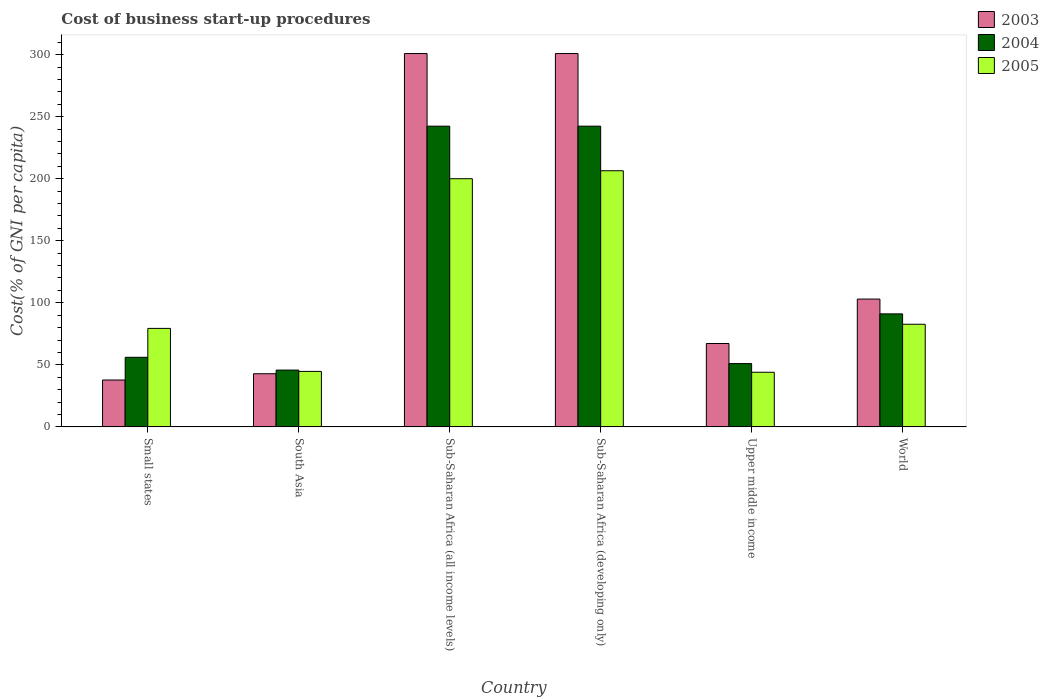How many different coloured bars are there?
Offer a very short reply. 3. How many bars are there on the 5th tick from the left?
Offer a very short reply. 3. How many bars are there on the 5th tick from the right?
Make the answer very short. 3. What is the label of the 1st group of bars from the left?
Offer a terse response. Small states. In how many cases, is the number of bars for a given country not equal to the number of legend labels?
Offer a terse response. 0. What is the cost of business start-up procedures in 2003 in Sub-Saharan Africa (developing only)?
Provide a short and direct response. 300.87. Across all countries, what is the maximum cost of business start-up procedures in 2005?
Provide a short and direct response. 206.42. Across all countries, what is the minimum cost of business start-up procedures in 2004?
Offer a terse response. 45.76. In which country was the cost of business start-up procedures in 2005 maximum?
Your answer should be very brief. Sub-Saharan Africa (developing only). In which country was the cost of business start-up procedures in 2005 minimum?
Offer a terse response. Upper middle income. What is the total cost of business start-up procedures in 2004 in the graph?
Your answer should be compact. 728.58. What is the difference between the cost of business start-up procedures in 2004 in Small states and that in World?
Your answer should be compact. -34.99. What is the difference between the cost of business start-up procedures in 2004 in Sub-Saharan Africa (developing only) and the cost of business start-up procedures in 2003 in Small states?
Make the answer very short. 204.57. What is the average cost of business start-up procedures in 2003 per country?
Your answer should be very brief. 142.09. What is the difference between the cost of business start-up procedures of/in 2005 and cost of business start-up procedures of/in 2003 in Small states?
Give a very brief answer. 41.58. What is the ratio of the cost of business start-up procedures in 2004 in South Asia to that in World?
Your response must be concise. 0.5. What is the difference between the highest and the second highest cost of business start-up procedures in 2004?
Provide a succinct answer. 151.29. What is the difference between the highest and the lowest cost of business start-up procedures in 2004?
Offer a very short reply. 196.59. In how many countries, is the cost of business start-up procedures in 2004 greater than the average cost of business start-up procedures in 2004 taken over all countries?
Provide a succinct answer. 2. Is the sum of the cost of business start-up procedures in 2005 in Small states and Sub-Saharan Africa (developing only) greater than the maximum cost of business start-up procedures in 2003 across all countries?
Give a very brief answer. No. What does the 3rd bar from the left in Sub-Saharan Africa (developing only) represents?
Your answer should be very brief. 2005. Is it the case that in every country, the sum of the cost of business start-up procedures in 2005 and cost of business start-up procedures in 2004 is greater than the cost of business start-up procedures in 2003?
Your response must be concise. Yes. Are all the bars in the graph horizontal?
Keep it short and to the point. No. Are the values on the major ticks of Y-axis written in scientific E-notation?
Provide a succinct answer. No. Does the graph contain grids?
Your response must be concise. No. What is the title of the graph?
Ensure brevity in your answer.  Cost of business start-up procedures. Does "1974" appear as one of the legend labels in the graph?
Make the answer very short. No. What is the label or title of the Y-axis?
Offer a terse response. Cost(% of GNI per capita). What is the Cost(% of GNI per capita) of 2003 in Small states?
Make the answer very short. 37.77. What is the Cost(% of GNI per capita) in 2004 in Small states?
Your answer should be very brief. 56.07. What is the Cost(% of GNI per capita) in 2005 in Small states?
Keep it short and to the point. 79.36. What is the Cost(% of GNI per capita) of 2003 in South Asia?
Your answer should be very brief. 42.83. What is the Cost(% of GNI per capita) in 2004 in South Asia?
Offer a terse response. 45.76. What is the Cost(% of GNI per capita) of 2005 in South Asia?
Your response must be concise. 44.7. What is the Cost(% of GNI per capita) of 2003 in Sub-Saharan Africa (all income levels)?
Keep it short and to the point. 300.87. What is the Cost(% of GNI per capita) in 2004 in Sub-Saharan Africa (all income levels)?
Give a very brief answer. 242.35. What is the Cost(% of GNI per capita) of 2005 in Sub-Saharan Africa (all income levels)?
Your answer should be compact. 200. What is the Cost(% of GNI per capita) in 2003 in Sub-Saharan Africa (developing only)?
Offer a very short reply. 300.87. What is the Cost(% of GNI per capita) in 2004 in Sub-Saharan Africa (developing only)?
Provide a short and direct response. 242.35. What is the Cost(% of GNI per capita) of 2005 in Sub-Saharan Africa (developing only)?
Provide a short and direct response. 206.42. What is the Cost(% of GNI per capita) of 2003 in Upper middle income?
Make the answer very short. 67.19. What is the Cost(% of GNI per capita) in 2004 in Upper middle income?
Ensure brevity in your answer.  51. What is the Cost(% of GNI per capita) of 2005 in Upper middle income?
Provide a succinct answer. 44.01. What is the Cost(% of GNI per capita) in 2003 in World?
Your answer should be compact. 103. What is the Cost(% of GNI per capita) of 2004 in World?
Offer a very short reply. 91.06. What is the Cost(% of GNI per capita) of 2005 in World?
Ensure brevity in your answer.  82.7. Across all countries, what is the maximum Cost(% of GNI per capita) of 2003?
Your response must be concise. 300.87. Across all countries, what is the maximum Cost(% of GNI per capita) of 2004?
Keep it short and to the point. 242.35. Across all countries, what is the maximum Cost(% of GNI per capita) in 2005?
Your answer should be very brief. 206.42. Across all countries, what is the minimum Cost(% of GNI per capita) of 2003?
Provide a succinct answer. 37.77. Across all countries, what is the minimum Cost(% of GNI per capita) in 2004?
Ensure brevity in your answer.  45.76. Across all countries, what is the minimum Cost(% of GNI per capita) in 2005?
Your response must be concise. 44.01. What is the total Cost(% of GNI per capita) in 2003 in the graph?
Keep it short and to the point. 852.52. What is the total Cost(% of GNI per capita) in 2004 in the graph?
Make the answer very short. 728.58. What is the total Cost(% of GNI per capita) in 2005 in the graph?
Make the answer very short. 657.18. What is the difference between the Cost(% of GNI per capita) of 2003 in Small states and that in South Asia?
Your answer should be compact. -5.05. What is the difference between the Cost(% of GNI per capita) in 2004 in Small states and that in South Asia?
Provide a succinct answer. 10.31. What is the difference between the Cost(% of GNI per capita) in 2005 in Small states and that in South Asia?
Offer a very short reply. 34.66. What is the difference between the Cost(% of GNI per capita) of 2003 in Small states and that in Sub-Saharan Africa (all income levels)?
Your answer should be very brief. -263.1. What is the difference between the Cost(% of GNI per capita) of 2004 in Small states and that in Sub-Saharan Africa (all income levels)?
Your answer should be compact. -186.28. What is the difference between the Cost(% of GNI per capita) of 2005 in Small states and that in Sub-Saharan Africa (all income levels)?
Your response must be concise. -120.64. What is the difference between the Cost(% of GNI per capita) in 2003 in Small states and that in Sub-Saharan Africa (developing only)?
Ensure brevity in your answer.  -263.1. What is the difference between the Cost(% of GNI per capita) of 2004 in Small states and that in Sub-Saharan Africa (developing only)?
Give a very brief answer. -186.28. What is the difference between the Cost(% of GNI per capita) of 2005 in Small states and that in Sub-Saharan Africa (developing only)?
Ensure brevity in your answer.  -127.06. What is the difference between the Cost(% of GNI per capita) of 2003 in Small states and that in Upper middle income?
Ensure brevity in your answer.  -29.42. What is the difference between the Cost(% of GNI per capita) in 2004 in Small states and that in Upper middle income?
Offer a terse response. 5.07. What is the difference between the Cost(% of GNI per capita) of 2005 in Small states and that in Upper middle income?
Offer a very short reply. 35.35. What is the difference between the Cost(% of GNI per capita) of 2003 in Small states and that in World?
Provide a succinct answer. -65.22. What is the difference between the Cost(% of GNI per capita) in 2004 in Small states and that in World?
Keep it short and to the point. -34.99. What is the difference between the Cost(% of GNI per capita) in 2005 in Small states and that in World?
Provide a succinct answer. -3.34. What is the difference between the Cost(% of GNI per capita) of 2003 in South Asia and that in Sub-Saharan Africa (all income levels)?
Your answer should be compact. -258.04. What is the difference between the Cost(% of GNI per capita) of 2004 in South Asia and that in Sub-Saharan Africa (all income levels)?
Your answer should be very brief. -196.59. What is the difference between the Cost(% of GNI per capita) in 2005 in South Asia and that in Sub-Saharan Africa (all income levels)?
Give a very brief answer. -155.3. What is the difference between the Cost(% of GNI per capita) in 2003 in South Asia and that in Sub-Saharan Africa (developing only)?
Provide a short and direct response. -258.04. What is the difference between the Cost(% of GNI per capita) in 2004 in South Asia and that in Sub-Saharan Africa (developing only)?
Ensure brevity in your answer.  -196.59. What is the difference between the Cost(% of GNI per capita) of 2005 in South Asia and that in Sub-Saharan Africa (developing only)?
Make the answer very short. -161.72. What is the difference between the Cost(% of GNI per capita) of 2003 in South Asia and that in Upper middle income?
Make the answer very short. -24.36. What is the difference between the Cost(% of GNI per capita) in 2004 in South Asia and that in Upper middle income?
Your response must be concise. -5.24. What is the difference between the Cost(% of GNI per capita) in 2005 in South Asia and that in Upper middle income?
Your answer should be compact. 0.69. What is the difference between the Cost(% of GNI per capita) of 2003 in South Asia and that in World?
Your answer should be compact. -60.17. What is the difference between the Cost(% of GNI per capita) in 2004 in South Asia and that in World?
Offer a very short reply. -45.3. What is the difference between the Cost(% of GNI per capita) of 2005 in South Asia and that in World?
Offer a terse response. -38. What is the difference between the Cost(% of GNI per capita) in 2003 in Sub-Saharan Africa (all income levels) and that in Sub-Saharan Africa (developing only)?
Give a very brief answer. 0. What is the difference between the Cost(% of GNI per capita) in 2004 in Sub-Saharan Africa (all income levels) and that in Sub-Saharan Africa (developing only)?
Your response must be concise. 0. What is the difference between the Cost(% of GNI per capita) of 2005 in Sub-Saharan Africa (all income levels) and that in Sub-Saharan Africa (developing only)?
Keep it short and to the point. -6.42. What is the difference between the Cost(% of GNI per capita) in 2003 in Sub-Saharan Africa (all income levels) and that in Upper middle income?
Ensure brevity in your answer.  233.68. What is the difference between the Cost(% of GNI per capita) of 2004 in Sub-Saharan Africa (all income levels) and that in Upper middle income?
Ensure brevity in your answer.  191.35. What is the difference between the Cost(% of GNI per capita) of 2005 in Sub-Saharan Africa (all income levels) and that in Upper middle income?
Provide a short and direct response. 155.99. What is the difference between the Cost(% of GNI per capita) in 2003 in Sub-Saharan Africa (all income levels) and that in World?
Ensure brevity in your answer.  197.87. What is the difference between the Cost(% of GNI per capita) of 2004 in Sub-Saharan Africa (all income levels) and that in World?
Provide a succinct answer. 151.29. What is the difference between the Cost(% of GNI per capita) in 2005 in Sub-Saharan Africa (all income levels) and that in World?
Provide a short and direct response. 117.3. What is the difference between the Cost(% of GNI per capita) of 2003 in Sub-Saharan Africa (developing only) and that in Upper middle income?
Ensure brevity in your answer.  233.68. What is the difference between the Cost(% of GNI per capita) of 2004 in Sub-Saharan Africa (developing only) and that in Upper middle income?
Offer a very short reply. 191.35. What is the difference between the Cost(% of GNI per capita) in 2005 in Sub-Saharan Africa (developing only) and that in Upper middle income?
Make the answer very short. 162.41. What is the difference between the Cost(% of GNI per capita) in 2003 in Sub-Saharan Africa (developing only) and that in World?
Give a very brief answer. 197.87. What is the difference between the Cost(% of GNI per capita) of 2004 in Sub-Saharan Africa (developing only) and that in World?
Offer a terse response. 151.29. What is the difference between the Cost(% of GNI per capita) of 2005 in Sub-Saharan Africa (developing only) and that in World?
Provide a short and direct response. 123.72. What is the difference between the Cost(% of GNI per capita) in 2003 in Upper middle income and that in World?
Keep it short and to the point. -35.81. What is the difference between the Cost(% of GNI per capita) in 2004 in Upper middle income and that in World?
Your response must be concise. -40.06. What is the difference between the Cost(% of GNI per capita) of 2005 in Upper middle income and that in World?
Offer a terse response. -38.69. What is the difference between the Cost(% of GNI per capita) of 2003 in Small states and the Cost(% of GNI per capita) of 2004 in South Asia?
Your response must be concise. -7.99. What is the difference between the Cost(% of GNI per capita) of 2003 in Small states and the Cost(% of GNI per capita) of 2005 in South Asia?
Offer a terse response. -6.93. What is the difference between the Cost(% of GNI per capita) in 2004 in Small states and the Cost(% of GNI per capita) in 2005 in South Asia?
Offer a terse response. 11.37. What is the difference between the Cost(% of GNI per capita) in 2003 in Small states and the Cost(% of GNI per capita) in 2004 in Sub-Saharan Africa (all income levels)?
Offer a terse response. -204.57. What is the difference between the Cost(% of GNI per capita) of 2003 in Small states and the Cost(% of GNI per capita) of 2005 in Sub-Saharan Africa (all income levels)?
Your answer should be very brief. -162.22. What is the difference between the Cost(% of GNI per capita) of 2004 in Small states and the Cost(% of GNI per capita) of 2005 in Sub-Saharan Africa (all income levels)?
Your answer should be compact. -143.93. What is the difference between the Cost(% of GNI per capita) of 2003 in Small states and the Cost(% of GNI per capita) of 2004 in Sub-Saharan Africa (developing only)?
Ensure brevity in your answer.  -204.57. What is the difference between the Cost(% of GNI per capita) of 2003 in Small states and the Cost(% of GNI per capita) of 2005 in Sub-Saharan Africa (developing only)?
Ensure brevity in your answer.  -168.65. What is the difference between the Cost(% of GNI per capita) of 2004 in Small states and the Cost(% of GNI per capita) of 2005 in Sub-Saharan Africa (developing only)?
Your response must be concise. -150.35. What is the difference between the Cost(% of GNI per capita) in 2003 in Small states and the Cost(% of GNI per capita) in 2004 in Upper middle income?
Your answer should be very brief. -13.22. What is the difference between the Cost(% of GNI per capita) of 2003 in Small states and the Cost(% of GNI per capita) of 2005 in Upper middle income?
Your answer should be very brief. -6.24. What is the difference between the Cost(% of GNI per capita) in 2004 in Small states and the Cost(% of GNI per capita) in 2005 in Upper middle income?
Give a very brief answer. 12.06. What is the difference between the Cost(% of GNI per capita) in 2003 in Small states and the Cost(% of GNI per capita) in 2004 in World?
Your answer should be compact. -53.29. What is the difference between the Cost(% of GNI per capita) of 2003 in Small states and the Cost(% of GNI per capita) of 2005 in World?
Your answer should be very brief. -44.93. What is the difference between the Cost(% of GNI per capita) in 2004 in Small states and the Cost(% of GNI per capita) in 2005 in World?
Offer a terse response. -26.63. What is the difference between the Cost(% of GNI per capita) of 2003 in South Asia and the Cost(% of GNI per capita) of 2004 in Sub-Saharan Africa (all income levels)?
Your answer should be compact. -199.52. What is the difference between the Cost(% of GNI per capita) in 2003 in South Asia and the Cost(% of GNI per capita) in 2005 in Sub-Saharan Africa (all income levels)?
Make the answer very short. -157.17. What is the difference between the Cost(% of GNI per capita) in 2004 in South Asia and the Cost(% of GNI per capita) in 2005 in Sub-Saharan Africa (all income levels)?
Ensure brevity in your answer.  -154.24. What is the difference between the Cost(% of GNI per capita) of 2003 in South Asia and the Cost(% of GNI per capita) of 2004 in Sub-Saharan Africa (developing only)?
Offer a very short reply. -199.52. What is the difference between the Cost(% of GNI per capita) of 2003 in South Asia and the Cost(% of GNI per capita) of 2005 in Sub-Saharan Africa (developing only)?
Your response must be concise. -163.59. What is the difference between the Cost(% of GNI per capita) in 2004 in South Asia and the Cost(% of GNI per capita) in 2005 in Sub-Saharan Africa (developing only)?
Your answer should be very brief. -160.66. What is the difference between the Cost(% of GNI per capita) in 2003 in South Asia and the Cost(% of GNI per capita) in 2004 in Upper middle income?
Provide a short and direct response. -8.17. What is the difference between the Cost(% of GNI per capita) in 2003 in South Asia and the Cost(% of GNI per capita) in 2005 in Upper middle income?
Offer a terse response. -1.18. What is the difference between the Cost(% of GNI per capita) in 2004 in South Asia and the Cost(% of GNI per capita) in 2005 in Upper middle income?
Ensure brevity in your answer.  1.75. What is the difference between the Cost(% of GNI per capita) of 2003 in South Asia and the Cost(% of GNI per capita) of 2004 in World?
Keep it short and to the point. -48.24. What is the difference between the Cost(% of GNI per capita) of 2003 in South Asia and the Cost(% of GNI per capita) of 2005 in World?
Provide a short and direct response. -39.88. What is the difference between the Cost(% of GNI per capita) in 2004 in South Asia and the Cost(% of GNI per capita) in 2005 in World?
Make the answer very short. -36.94. What is the difference between the Cost(% of GNI per capita) in 2003 in Sub-Saharan Africa (all income levels) and the Cost(% of GNI per capita) in 2004 in Sub-Saharan Africa (developing only)?
Provide a short and direct response. 58.52. What is the difference between the Cost(% of GNI per capita) in 2003 in Sub-Saharan Africa (all income levels) and the Cost(% of GNI per capita) in 2005 in Sub-Saharan Africa (developing only)?
Make the answer very short. 94.45. What is the difference between the Cost(% of GNI per capita) of 2004 in Sub-Saharan Africa (all income levels) and the Cost(% of GNI per capita) of 2005 in Sub-Saharan Africa (developing only)?
Provide a short and direct response. 35.93. What is the difference between the Cost(% of GNI per capita) in 2003 in Sub-Saharan Africa (all income levels) and the Cost(% of GNI per capita) in 2004 in Upper middle income?
Your answer should be compact. 249.87. What is the difference between the Cost(% of GNI per capita) of 2003 in Sub-Saharan Africa (all income levels) and the Cost(% of GNI per capita) of 2005 in Upper middle income?
Offer a very short reply. 256.86. What is the difference between the Cost(% of GNI per capita) of 2004 in Sub-Saharan Africa (all income levels) and the Cost(% of GNI per capita) of 2005 in Upper middle income?
Give a very brief answer. 198.34. What is the difference between the Cost(% of GNI per capita) of 2003 in Sub-Saharan Africa (all income levels) and the Cost(% of GNI per capita) of 2004 in World?
Your answer should be compact. 209.81. What is the difference between the Cost(% of GNI per capita) of 2003 in Sub-Saharan Africa (all income levels) and the Cost(% of GNI per capita) of 2005 in World?
Provide a succinct answer. 218.17. What is the difference between the Cost(% of GNI per capita) in 2004 in Sub-Saharan Africa (all income levels) and the Cost(% of GNI per capita) in 2005 in World?
Make the answer very short. 159.65. What is the difference between the Cost(% of GNI per capita) of 2003 in Sub-Saharan Africa (developing only) and the Cost(% of GNI per capita) of 2004 in Upper middle income?
Offer a terse response. 249.87. What is the difference between the Cost(% of GNI per capita) in 2003 in Sub-Saharan Africa (developing only) and the Cost(% of GNI per capita) in 2005 in Upper middle income?
Make the answer very short. 256.86. What is the difference between the Cost(% of GNI per capita) in 2004 in Sub-Saharan Africa (developing only) and the Cost(% of GNI per capita) in 2005 in Upper middle income?
Your answer should be very brief. 198.34. What is the difference between the Cost(% of GNI per capita) in 2003 in Sub-Saharan Africa (developing only) and the Cost(% of GNI per capita) in 2004 in World?
Provide a short and direct response. 209.81. What is the difference between the Cost(% of GNI per capita) in 2003 in Sub-Saharan Africa (developing only) and the Cost(% of GNI per capita) in 2005 in World?
Give a very brief answer. 218.17. What is the difference between the Cost(% of GNI per capita) in 2004 in Sub-Saharan Africa (developing only) and the Cost(% of GNI per capita) in 2005 in World?
Offer a terse response. 159.65. What is the difference between the Cost(% of GNI per capita) of 2003 in Upper middle income and the Cost(% of GNI per capita) of 2004 in World?
Ensure brevity in your answer.  -23.87. What is the difference between the Cost(% of GNI per capita) in 2003 in Upper middle income and the Cost(% of GNI per capita) in 2005 in World?
Provide a succinct answer. -15.51. What is the difference between the Cost(% of GNI per capita) in 2004 in Upper middle income and the Cost(% of GNI per capita) in 2005 in World?
Provide a succinct answer. -31.7. What is the average Cost(% of GNI per capita) of 2003 per country?
Your response must be concise. 142.09. What is the average Cost(% of GNI per capita) in 2004 per country?
Keep it short and to the point. 121.43. What is the average Cost(% of GNI per capita) in 2005 per country?
Your answer should be very brief. 109.53. What is the difference between the Cost(% of GNI per capita) in 2003 and Cost(% of GNI per capita) in 2004 in Small states?
Provide a short and direct response. -18.3. What is the difference between the Cost(% of GNI per capita) of 2003 and Cost(% of GNI per capita) of 2005 in Small states?
Offer a terse response. -41.58. What is the difference between the Cost(% of GNI per capita) in 2004 and Cost(% of GNI per capita) in 2005 in Small states?
Keep it short and to the point. -23.29. What is the difference between the Cost(% of GNI per capita) of 2003 and Cost(% of GNI per capita) of 2004 in South Asia?
Your answer should be compact. -2.94. What is the difference between the Cost(% of GNI per capita) of 2003 and Cost(% of GNI per capita) of 2005 in South Asia?
Offer a very short reply. -1.88. What is the difference between the Cost(% of GNI per capita) of 2004 and Cost(% of GNI per capita) of 2005 in South Asia?
Keep it short and to the point. 1.06. What is the difference between the Cost(% of GNI per capita) of 2003 and Cost(% of GNI per capita) of 2004 in Sub-Saharan Africa (all income levels)?
Make the answer very short. 58.52. What is the difference between the Cost(% of GNI per capita) in 2003 and Cost(% of GNI per capita) in 2005 in Sub-Saharan Africa (all income levels)?
Ensure brevity in your answer.  100.87. What is the difference between the Cost(% of GNI per capita) of 2004 and Cost(% of GNI per capita) of 2005 in Sub-Saharan Africa (all income levels)?
Offer a very short reply. 42.35. What is the difference between the Cost(% of GNI per capita) of 2003 and Cost(% of GNI per capita) of 2004 in Sub-Saharan Africa (developing only)?
Your answer should be compact. 58.52. What is the difference between the Cost(% of GNI per capita) in 2003 and Cost(% of GNI per capita) in 2005 in Sub-Saharan Africa (developing only)?
Ensure brevity in your answer.  94.45. What is the difference between the Cost(% of GNI per capita) of 2004 and Cost(% of GNI per capita) of 2005 in Sub-Saharan Africa (developing only)?
Offer a very short reply. 35.93. What is the difference between the Cost(% of GNI per capita) of 2003 and Cost(% of GNI per capita) of 2004 in Upper middle income?
Your response must be concise. 16.19. What is the difference between the Cost(% of GNI per capita) of 2003 and Cost(% of GNI per capita) of 2005 in Upper middle income?
Your answer should be compact. 23.18. What is the difference between the Cost(% of GNI per capita) of 2004 and Cost(% of GNI per capita) of 2005 in Upper middle income?
Make the answer very short. 6.99. What is the difference between the Cost(% of GNI per capita) in 2003 and Cost(% of GNI per capita) in 2004 in World?
Your answer should be very brief. 11.94. What is the difference between the Cost(% of GNI per capita) in 2003 and Cost(% of GNI per capita) in 2005 in World?
Make the answer very short. 20.3. What is the difference between the Cost(% of GNI per capita) of 2004 and Cost(% of GNI per capita) of 2005 in World?
Ensure brevity in your answer.  8.36. What is the ratio of the Cost(% of GNI per capita) in 2003 in Small states to that in South Asia?
Your response must be concise. 0.88. What is the ratio of the Cost(% of GNI per capita) in 2004 in Small states to that in South Asia?
Give a very brief answer. 1.23. What is the ratio of the Cost(% of GNI per capita) of 2005 in Small states to that in South Asia?
Provide a short and direct response. 1.78. What is the ratio of the Cost(% of GNI per capita) in 2003 in Small states to that in Sub-Saharan Africa (all income levels)?
Keep it short and to the point. 0.13. What is the ratio of the Cost(% of GNI per capita) in 2004 in Small states to that in Sub-Saharan Africa (all income levels)?
Your answer should be compact. 0.23. What is the ratio of the Cost(% of GNI per capita) of 2005 in Small states to that in Sub-Saharan Africa (all income levels)?
Your answer should be compact. 0.4. What is the ratio of the Cost(% of GNI per capita) of 2003 in Small states to that in Sub-Saharan Africa (developing only)?
Offer a terse response. 0.13. What is the ratio of the Cost(% of GNI per capita) in 2004 in Small states to that in Sub-Saharan Africa (developing only)?
Offer a terse response. 0.23. What is the ratio of the Cost(% of GNI per capita) of 2005 in Small states to that in Sub-Saharan Africa (developing only)?
Provide a short and direct response. 0.38. What is the ratio of the Cost(% of GNI per capita) in 2003 in Small states to that in Upper middle income?
Ensure brevity in your answer.  0.56. What is the ratio of the Cost(% of GNI per capita) of 2004 in Small states to that in Upper middle income?
Your answer should be compact. 1.1. What is the ratio of the Cost(% of GNI per capita) in 2005 in Small states to that in Upper middle income?
Provide a short and direct response. 1.8. What is the ratio of the Cost(% of GNI per capita) of 2003 in Small states to that in World?
Your response must be concise. 0.37. What is the ratio of the Cost(% of GNI per capita) of 2004 in Small states to that in World?
Ensure brevity in your answer.  0.62. What is the ratio of the Cost(% of GNI per capita) of 2005 in Small states to that in World?
Keep it short and to the point. 0.96. What is the ratio of the Cost(% of GNI per capita) of 2003 in South Asia to that in Sub-Saharan Africa (all income levels)?
Give a very brief answer. 0.14. What is the ratio of the Cost(% of GNI per capita) in 2004 in South Asia to that in Sub-Saharan Africa (all income levels)?
Keep it short and to the point. 0.19. What is the ratio of the Cost(% of GNI per capita) in 2005 in South Asia to that in Sub-Saharan Africa (all income levels)?
Ensure brevity in your answer.  0.22. What is the ratio of the Cost(% of GNI per capita) in 2003 in South Asia to that in Sub-Saharan Africa (developing only)?
Offer a terse response. 0.14. What is the ratio of the Cost(% of GNI per capita) of 2004 in South Asia to that in Sub-Saharan Africa (developing only)?
Offer a very short reply. 0.19. What is the ratio of the Cost(% of GNI per capita) in 2005 in South Asia to that in Sub-Saharan Africa (developing only)?
Keep it short and to the point. 0.22. What is the ratio of the Cost(% of GNI per capita) of 2003 in South Asia to that in Upper middle income?
Provide a succinct answer. 0.64. What is the ratio of the Cost(% of GNI per capita) of 2004 in South Asia to that in Upper middle income?
Provide a short and direct response. 0.9. What is the ratio of the Cost(% of GNI per capita) of 2005 in South Asia to that in Upper middle income?
Your answer should be very brief. 1.02. What is the ratio of the Cost(% of GNI per capita) of 2003 in South Asia to that in World?
Your response must be concise. 0.42. What is the ratio of the Cost(% of GNI per capita) in 2004 in South Asia to that in World?
Offer a very short reply. 0.5. What is the ratio of the Cost(% of GNI per capita) of 2005 in South Asia to that in World?
Give a very brief answer. 0.54. What is the ratio of the Cost(% of GNI per capita) of 2004 in Sub-Saharan Africa (all income levels) to that in Sub-Saharan Africa (developing only)?
Keep it short and to the point. 1. What is the ratio of the Cost(% of GNI per capita) of 2005 in Sub-Saharan Africa (all income levels) to that in Sub-Saharan Africa (developing only)?
Give a very brief answer. 0.97. What is the ratio of the Cost(% of GNI per capita) of 2003 in Sub-Saharan Africa (all income levels) to that in Upper middle income?
Your answer should be compact. 4.48. What is the ratio of the Cost(% of GNI per capita) in 2004 in Sub-Saharan Africa (all income levels) to that in Upper middle income?
Give a very brief answer. 4.75. What is the ratio of the Cost(% of GNI per capita) in 2005 in Sub-Saharan Africa (all income levels) to that in Upper middle income?
Offer a terse response. 4.54. What is the ratio of the Cost(% of GNI per capita) in 2003 in Sub-Saharan Africa (all income levels) to that in World?
Ensure brevity in your answer.  2.92. What is the ratio of the Cost(% of GNI per capita) of 2004 in Sub-Saharan Africa (all income levels) to that in World?
Ensure brevity in your answer.  2.66. What is the ratio of the Cost(% of GNI per capita) of 2005 in Sub-Saharan Africa (all income levels) to that in World?
Provide a short and direct response. 2.42. What is the ratio of the Cost(% of GNI per capita) of 2003 in Sub-Saharan Africa (developing only) to that in Upper middle income?
Your answer should be very brief. 4.48. What is the ratio of the Cost(% of GNI per capita) in 2004 in Sub-Saharan Africa (developing only) to that in Upper middle income?
Your answer should be compact. 4.75. What is the ratio of the Cost(% of GNI per capita) of 2005 in Sub-Saharan Africa (developing only) to that in Upper middle income?
Give a very brief answer. 4.69. What is the ratio of the Cost(% of GNI per capita) of 2003 in Sub-Saharan Africa (developing only) to that in World?
Provide a short and direct response. 2.92. What is the ratio of the Cost(% of GNI per capita) of 2004 in Sub-Saharan Africa (developing only) to that in World?
Make the answer very short. 2.66. What is the ratio of the Cost(% of GNI per capita) in 2005 in Sub-Saharan Africa (developing only) to that in World?
Offer a terse response. 2.5. What is the ratio of the Cost(% of GNI per capita) of 2003 in Upper middle income to that in World?
Offer a terse response. 0.65. What is the ratio of the Cost(% of GNI per capita) of 2004 in Upper middle income to that in World?
Your answer should be very brief. 0.56. What is the ratio of the Cost(% of GNI per capita) of 2005 in Upper middle income to that in World?
Offer a very short reply. 0.53. What is the difference between the highest and the second highest Cost(% of GNI per capita) in 2003?
Provide a succinct answer. 0. What is the difference between the highest and the second highest Cost(% of GNI per capita) of 2004?
Provide a succinct answer. 0. What is the difference between the highest and the second highest Cost(% of GNI per capita) of 2005?
Your answer should be very brief. 6.42. What is the difference between the highest and the lowest Cost(% of GNI per capita) in 2003?
Your answer should be compact. 263.1. What is the difference between the highest and the lowest Cost(% of GNI per capita) of 2004?
Keep it short and to the point. 196.59. What is the difference between the highest and the lowest Cost(% of GNI per capita) in 2005?
Keep it short and to the point. 162.41. 